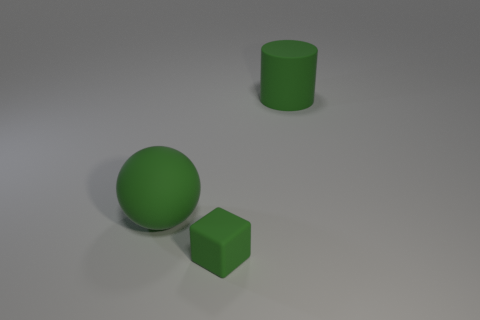Is the number of green rubber cubes that are in front of the matte block greater than the number of big green cylinders that are in front of the big rubber sphere?
Provide a short and direct response. No. There is a rubber thing that is on the right side of the large ball and behind the green rubber block; what is its shape?
Make the answer very short. Cylinder. There is a green matte thing that is to the left of the tiny green matte thing; what shape is it?
Provide a succinct answer. Sphere. There is a green rubber thing left of the thing in front of the ball behind the small green rubber thing; what size is it?
Your answer should be very brief. Large. What size is the green thing that is both behind the cube and on the right side of the large green ball?
Provide a succinct answer. Large. What material is the object behind the big matte thing on the left side of the big cylinder?
Provide a short and direct response. Rubber. Does the tiny green matte object have the same shape as the large green rubber object left of the large green cylinder?
Your response must be concise. No. What number of matte objects are green blocks or large red cylinders?
Make the answer very short. 1. There is a matte object that is behind the matte object that is on the left side of the green object in front of the ball; what is its color?
Make the answer very short. Green. How many other things are made of the same material as the large cylinder?
Make the answer very short. 2. 